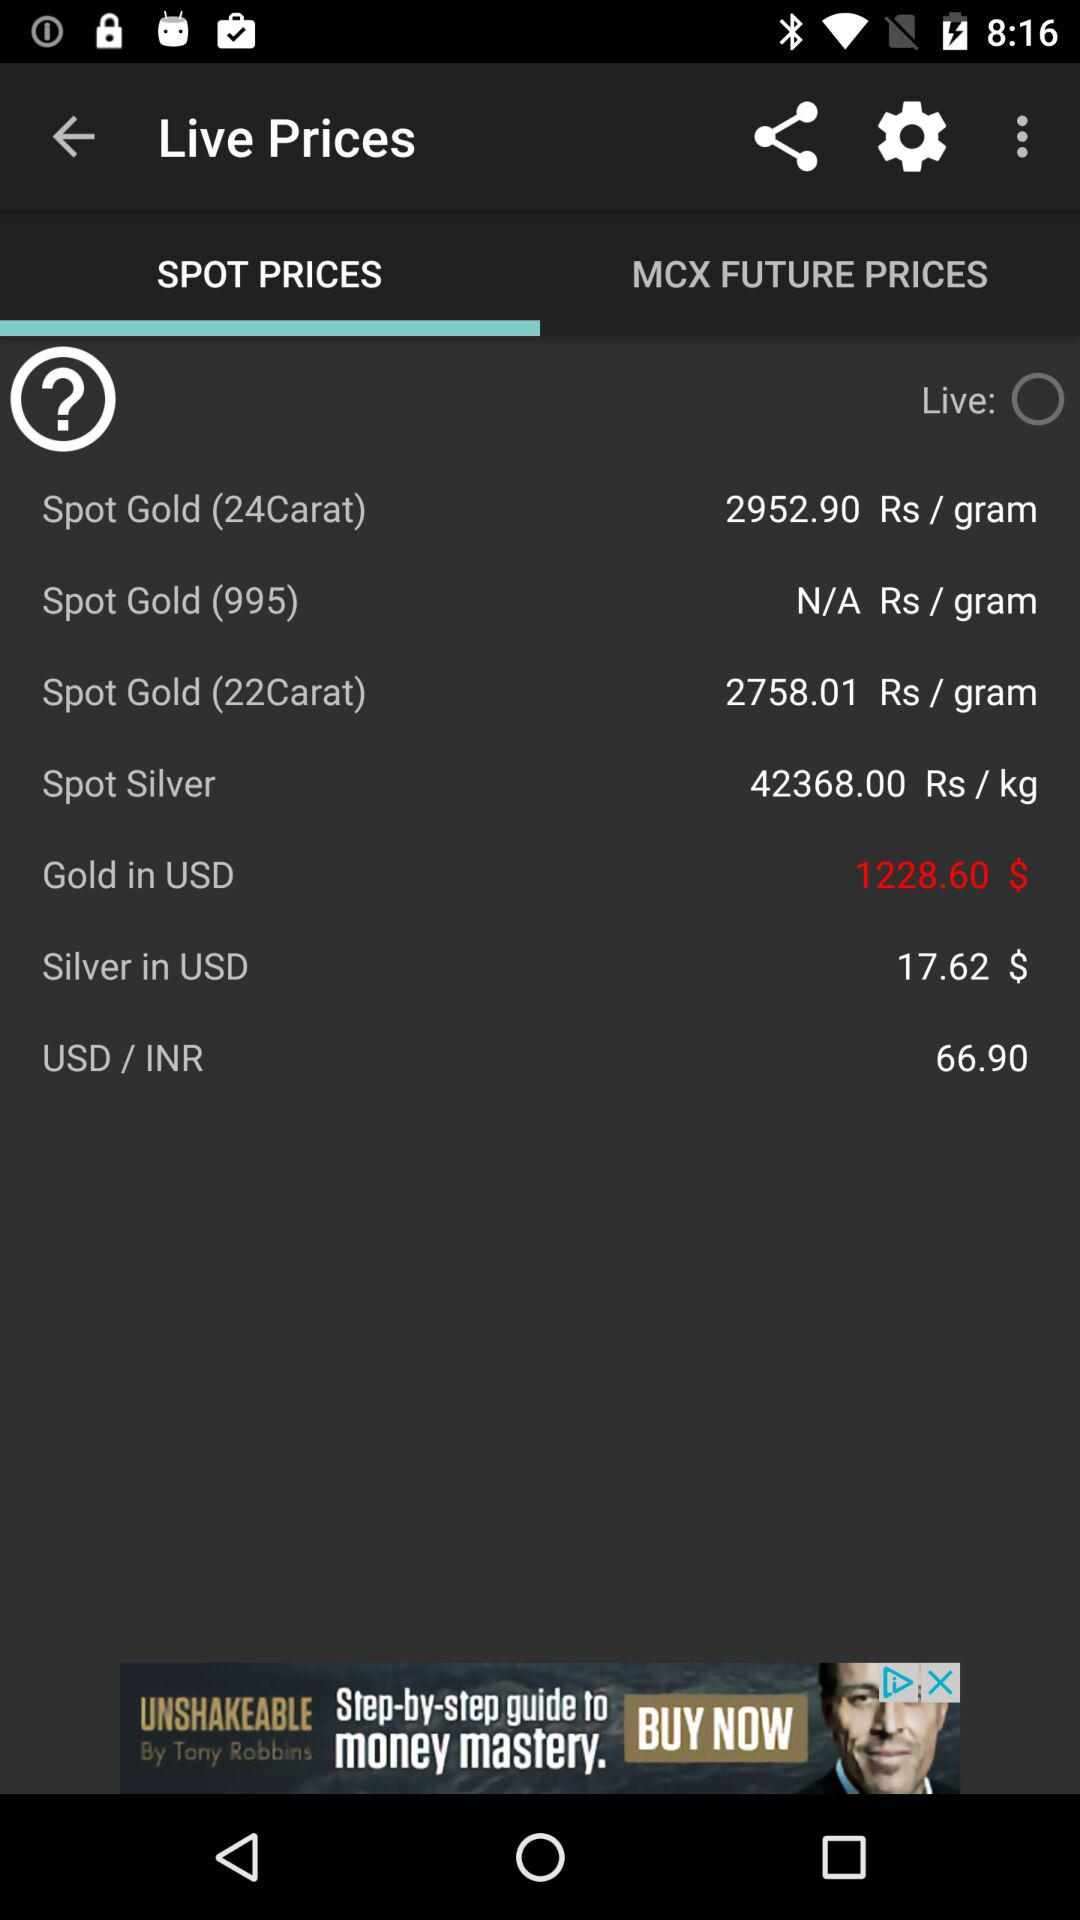What is the price of the spot gold of 24 carat? The price is Rs. 2952.90 per gram. 